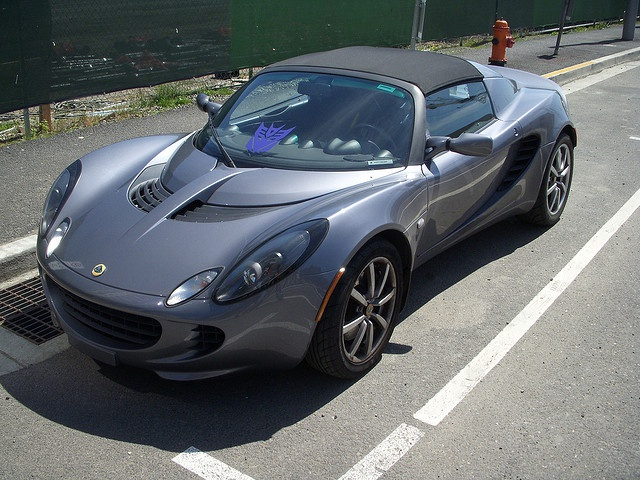Describe the objects in this image and their specific colors. I can see car in black and gray tones and fire hydrant in black, maroon, and gray tones in this image. 